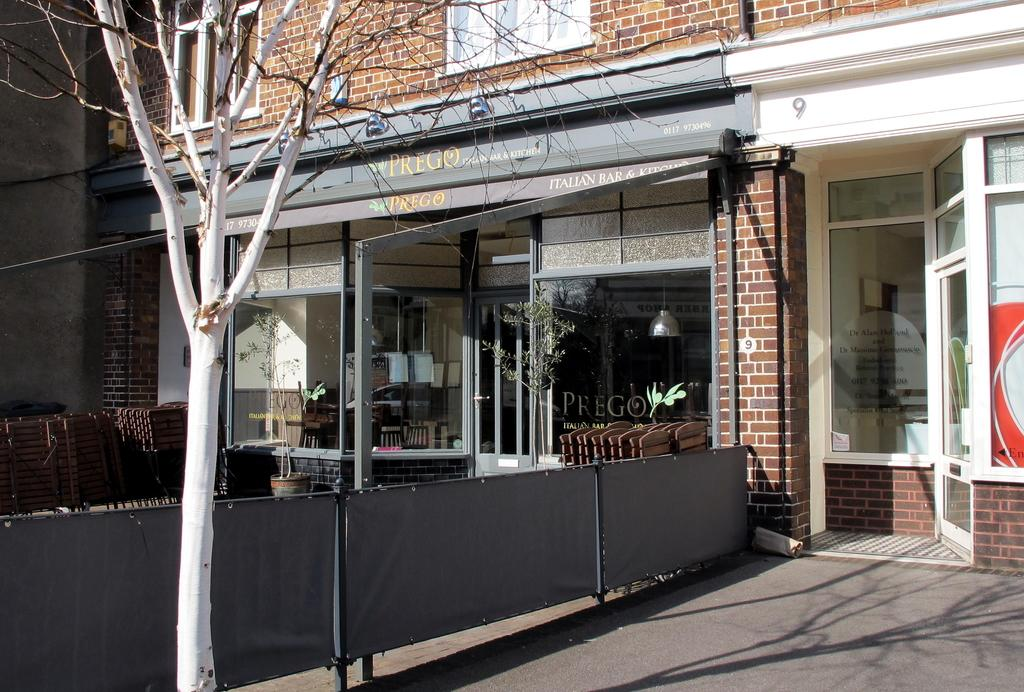What type of structure is visible in the image? There is a building with windows in the image. What is blocking the path or area in the image? There is a barricade in the image. What type of vegetation is present in the image? There is a tree in the image. What material is used for the boards in the image? The boards in the image are made of a material that is not specified in the facts. What is the plant in the image contained in? The plant in the image is in a pot. What type of lighting is present in the image? There is a ceiling lamp in the image. What is written or displayed on the glass windows in the image? There is text on the glass windows in the image. How many pairs of eyes can be seen in the image? There are no eyes visible in the image. What is the reason for the protest in the image? There is no protest present in the image. 